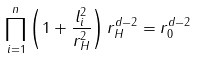<formula> <loc_0><loc_0><loc_500><loc_500>\prod _ { i = 1 } ^ { n } \left ( 1 + \frac { l _ { i } ^ { 2 } } { r _ { H } ^ { 2 } } \right ) r _ { H } ^ { d - 2 } = r _ { 0 } ^ { d - 2 }</formula> 